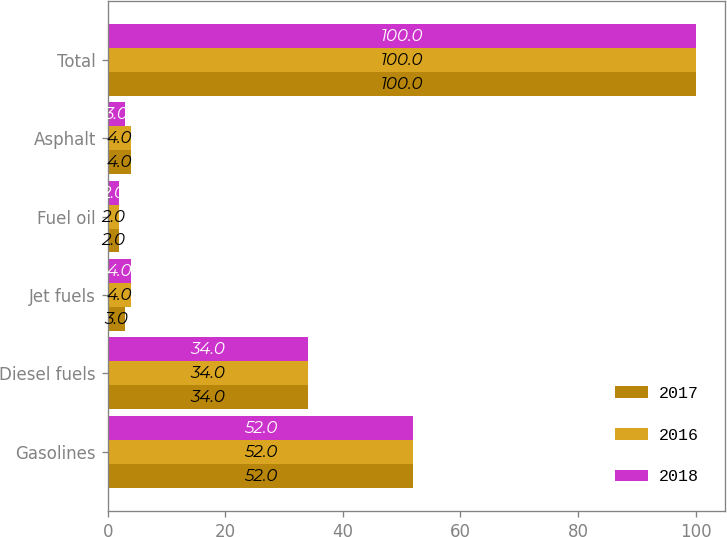Convert chart. <chart><loc_0><loc_0><loc_500><loc_500><stacked_bar_chart><ecel><fcel>Gasolines<fcel>Diesel fuels<fcel>Jet fuels<fcel>Fuel oil<fcel>Asphalt<fcel>Total<nl><fcel>2017<fcel>52<fcel>34<fcel>3<fcel>2<fcel>4<fcel>100<nl><fcel>2016<fcel>52<fcel>34<fcel>4<fcel>2<fcel>4<fcel>100<nl><fcel>2018<fcel>52<fcel>34<fcel>4<fcel>2<fcel>3<fcel>100<nl></chart> 